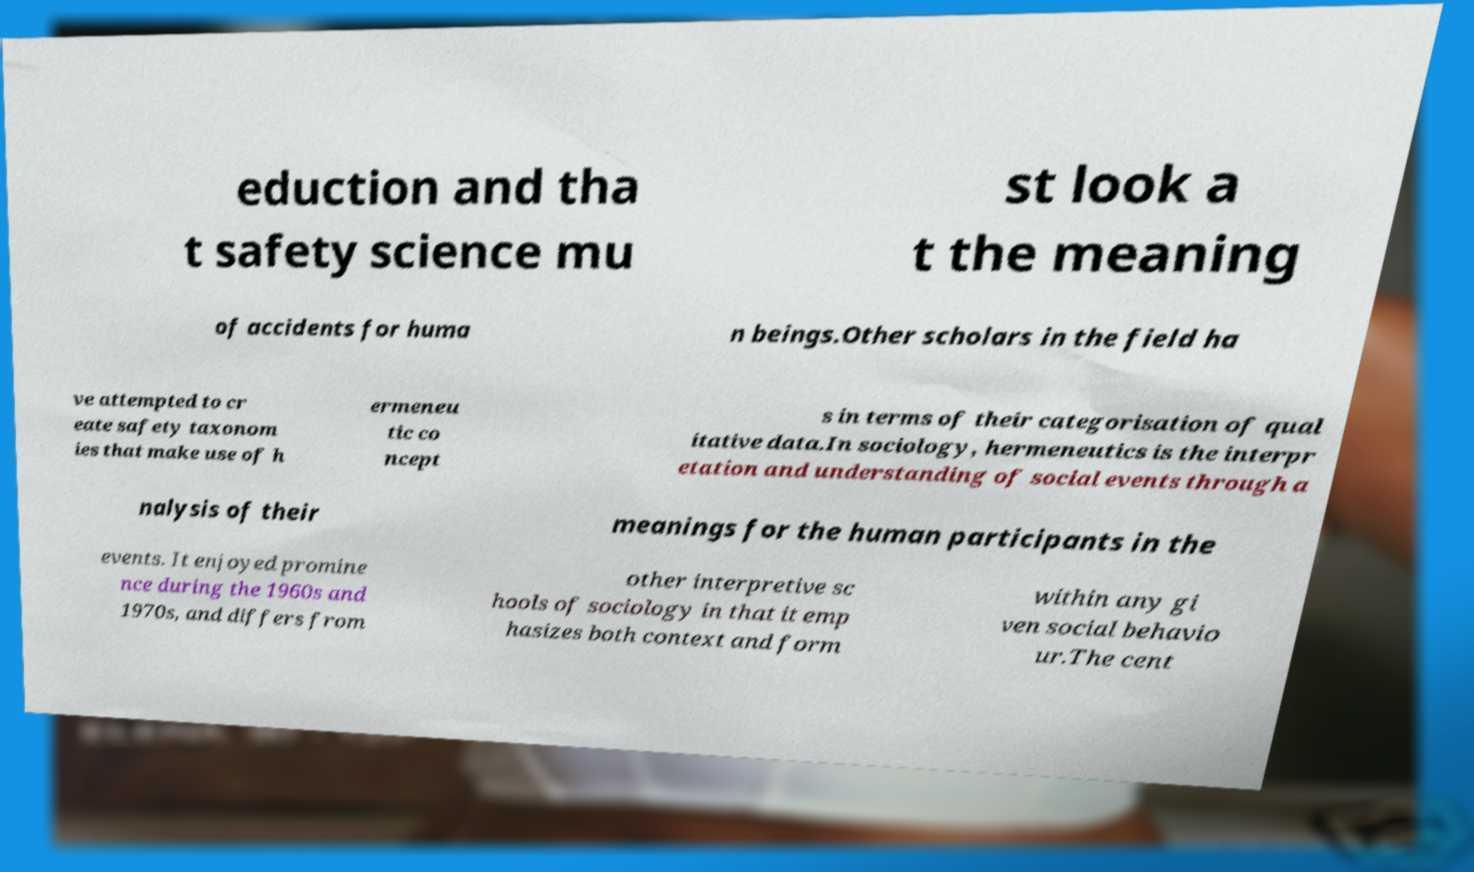Please identify and transcribe the text found in this image. eduction and tha t safety science mu st look a t the meaning of accidents for huma n beings.Other scholars in the field ha ve attempted to cr eate safety taxonom ies that make use of h ermeneu tic co ncept s in terms of their categorisation of qual itative data.In sociology, hermeneutics is the interpr etation and understanding of social events through a nalysis of their meanings for the human participants in the events. It enjoyed promine nce during the 1960s and 1970s, and differs from other interpretive sc hools of sociology in that it emp hasizes both context and form within any gi ven social behavio ur.The cent 